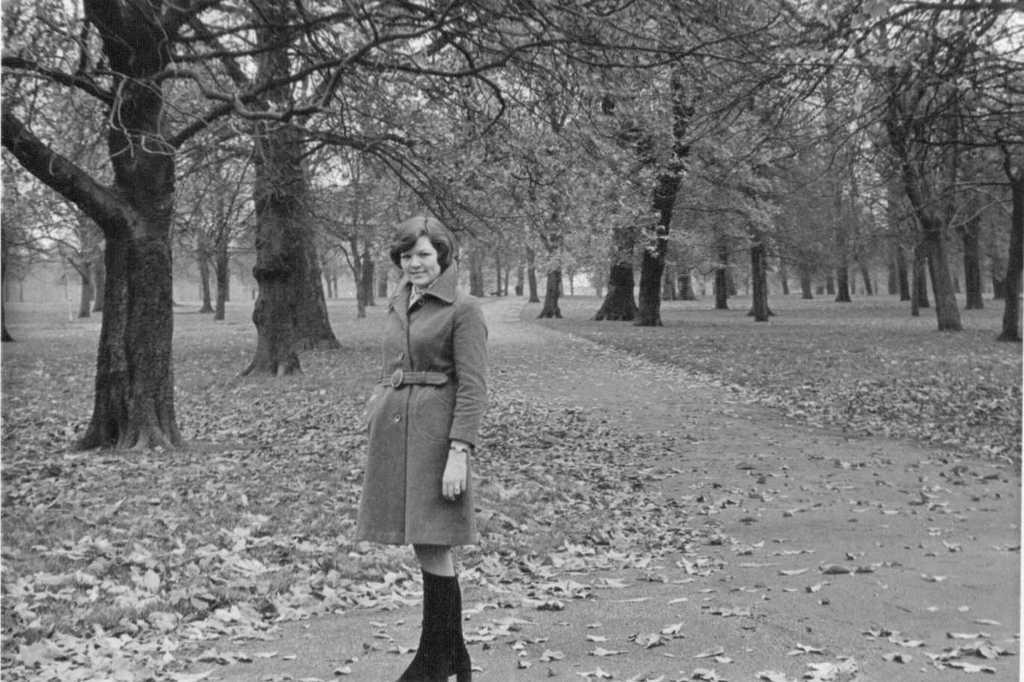Could you give a brief overview of what you see in this image? This picture shows a woman standing. She wore a coat and black shoes and we see trees and leaves on the ground. 